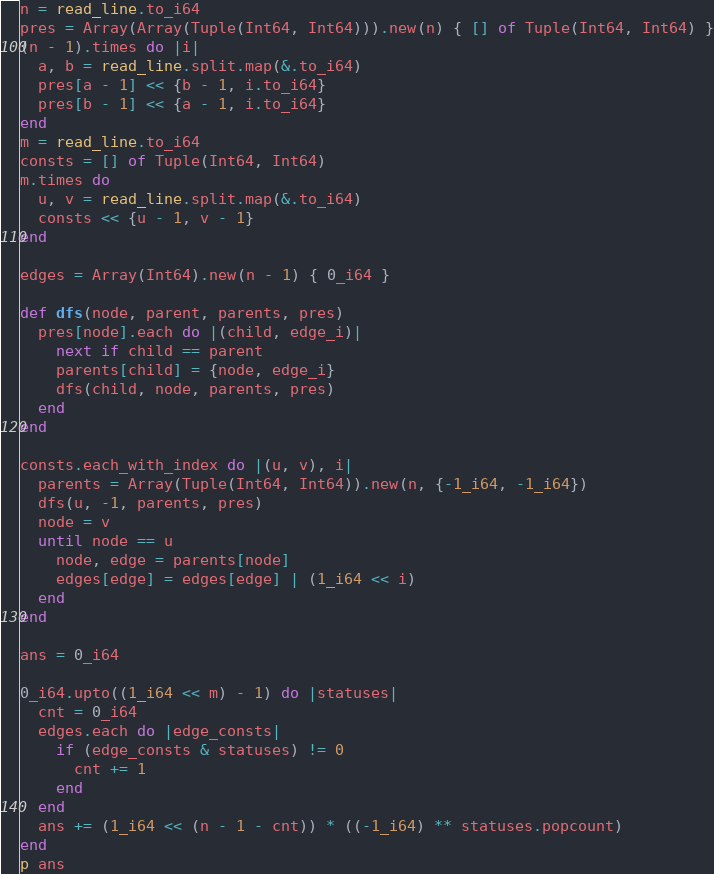<code> <loc_0><loc_0><loc_500><loc_500><_Crystal_>n = read_line.to_i64
pres = Array(Array(Tuple(Int64, Int64))).new(n) { [] of Tuple(Int64, Int64) }
(n - 1).times do |i|
  a, b = read_line.split.map(&.to_i64)
  pres[a - 1] << {b - 1, i.to_i64}
  pres[b - 1] << {a - 1, i.to_i64}
end
m = read_line.to_i64
consts = [] of Tuple(Int64, Int64)
m.times do
  u, v = read_line.split.map(&.to_i64)
  consts << {u - 1, v - 1}
end

edges = Array(Int64).new(n - 1) { 0_i64 }

def dfs(node, parent, parents, pres)
  pres[node].each do |(child, edge_i)|
    next if child == parent
    parents[child] = {node, edge_i}
    dfs(child, node, parents, pres)
  end
end

consts.each_with_index do |(u, v), i|
  parents = Array(Tuple(Int64, Int64)).new(n, {-1_i64, -1_i64})
  dfs(u, -1, parents, pres)
  node = v
  until node == u
    node, edge = parents[node]
    edges[edge] = edges[edge] | (1_i64 << i)
  end
end

ans = 0_i64

0_i64.upto((1_i64 << m) - 1) do |statuses|
  cnt = 0_i64
  edges.each do |edge_consts|
    if (edge_consts & statuses) != 0
      cnt += 1
    end
  end
  ans += (1_i64 << (n - 1 - cnt)) * ((-1_i64) ** statuses.popcount)
end
p ans
</code> 